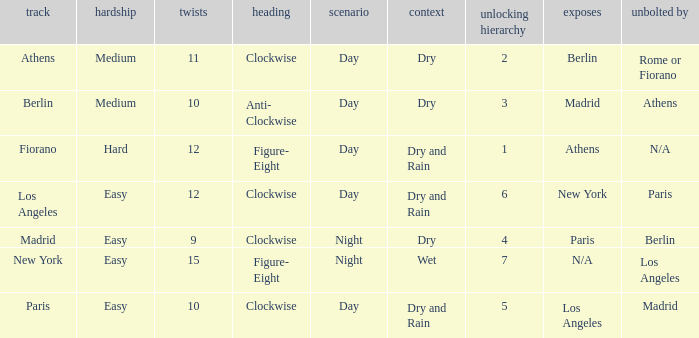How many instances is paris the unlock? 1.0. 